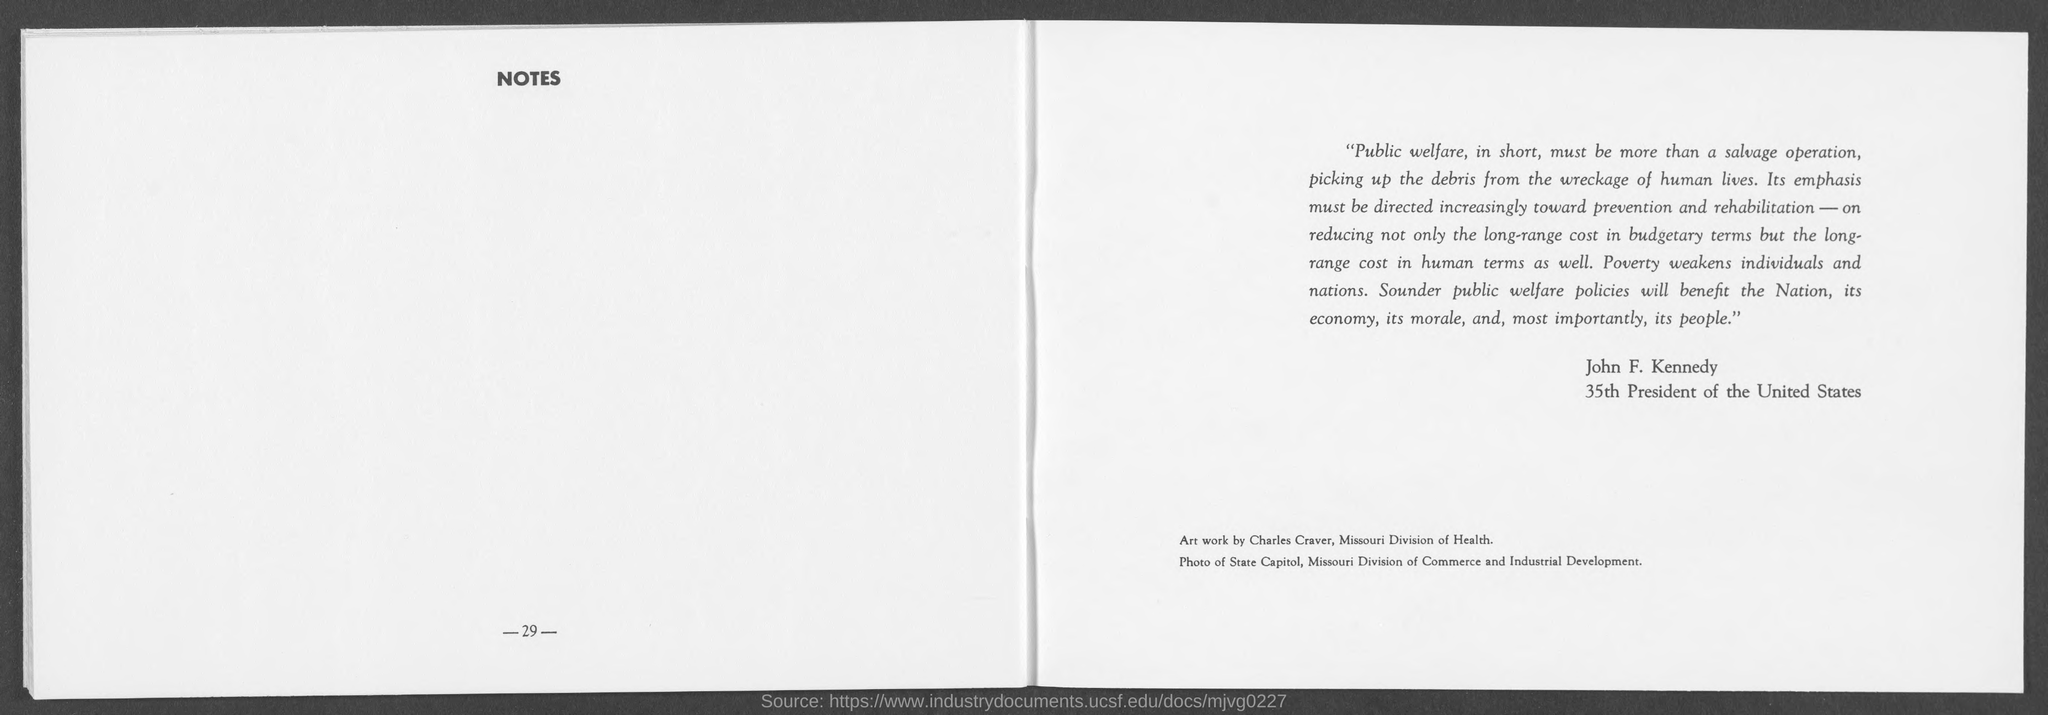Point out several critical features in this image. It is imperative that the aftermath of human lives be not simply a salvage operation, but rather a sustained effort to uplift and improve the general public's well-being. John F. Kennedy was the 35th President of the United States. 